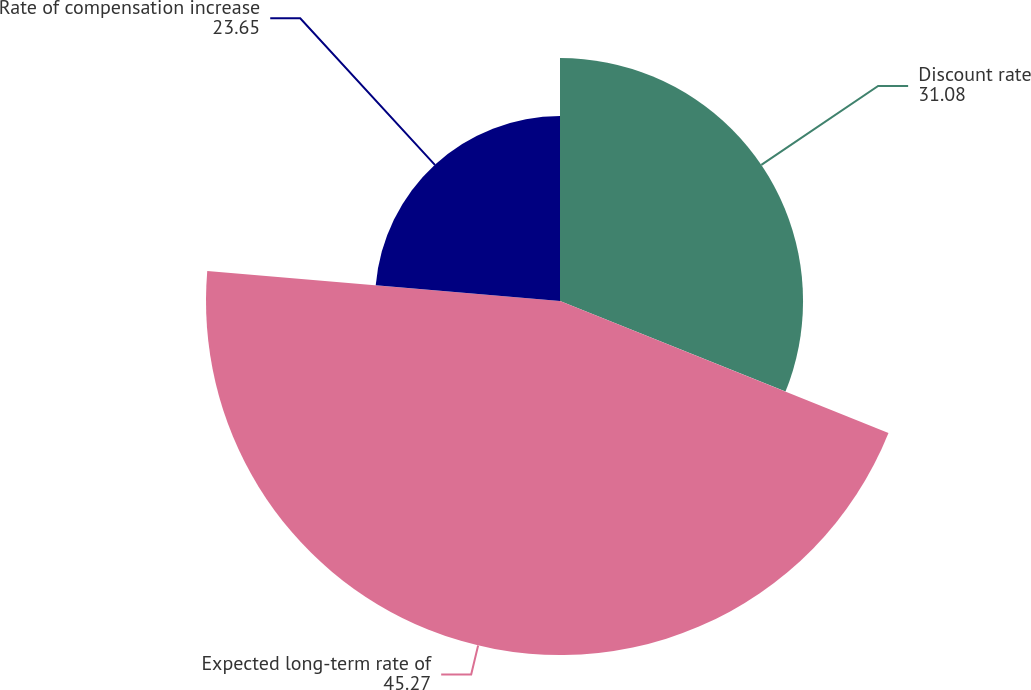Convert chart. <chart><loc_0><loc_0><loc_500><loc_500><pie_chart><fcel>Discount rate<fcel>Expected long-term rate of<fcel>Rate of compensation increase<nl><fcel>31.08%<fcel>45.27%<fcel>23.65%<nl></chart> 